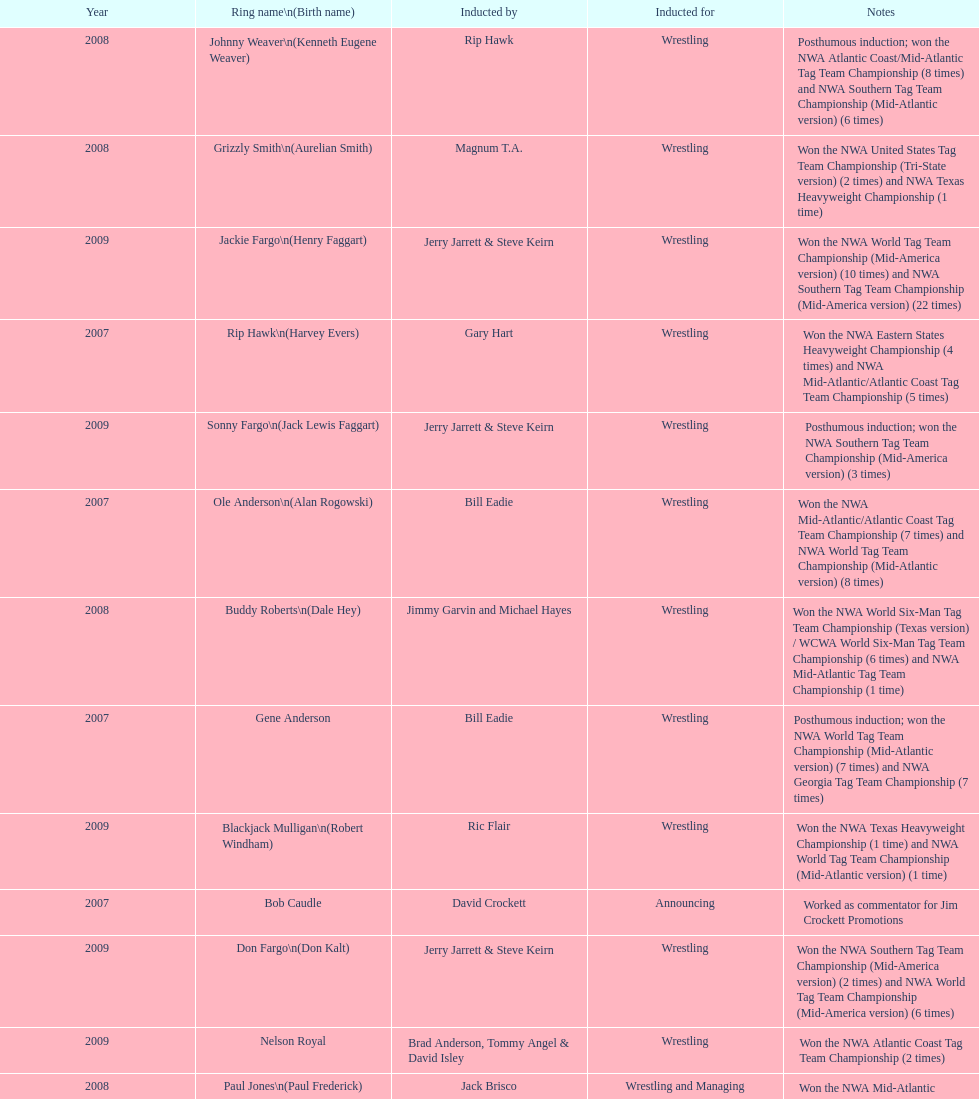Bob caudle was an announcer, who was the other one? Lance Russell. 